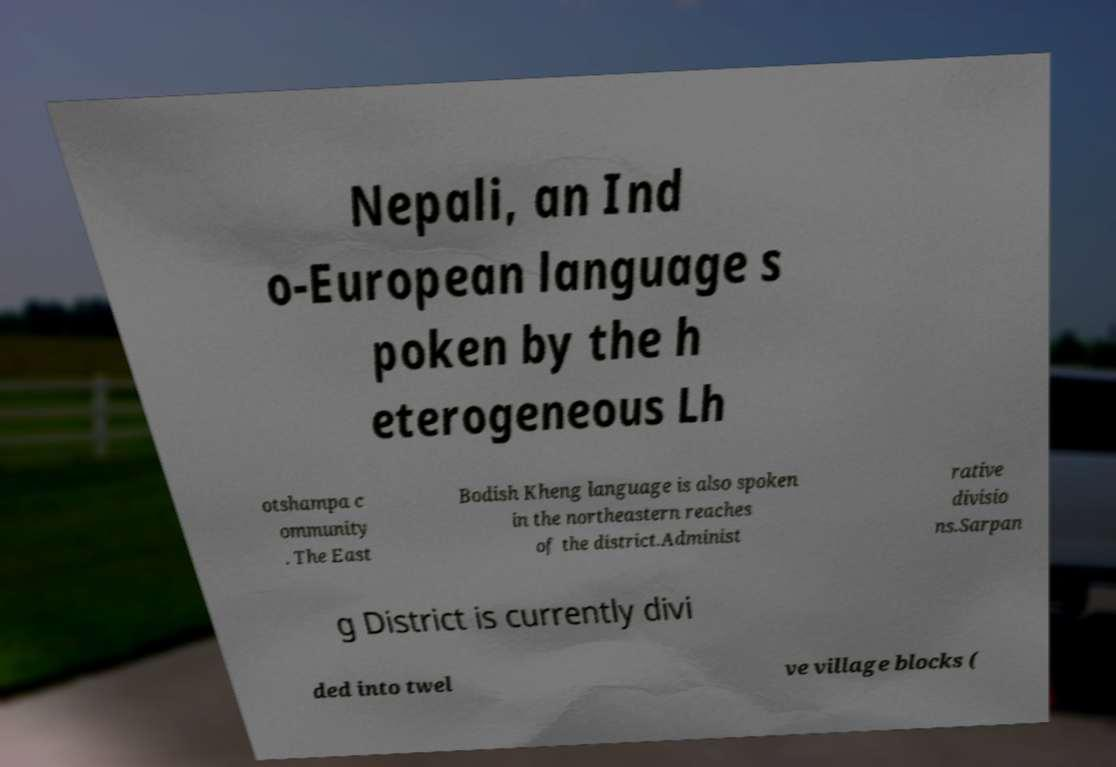Please identify and transcribe the text found in this image. Nepali, an Ind o-European language s poken by the h eterogeneous Lh otshampa c ommunity . The East Bodish Kheng language is also spoken in the northeastern reaches of the district.Administ rative divisio ns.Sarpan g District is currently divi ded into twel ve village blocks ( 